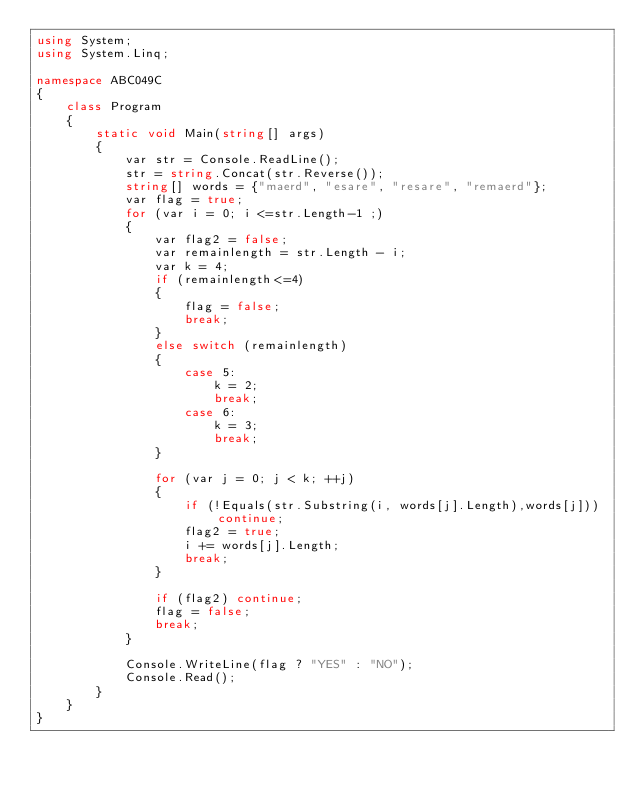Convert code to text. <code><loc_0><loc_0><loc_500><loc_500><_C#_>using System;
using System.Linq;

namespace ABC049C
{
    class Program
    {
        static void Main(string[] args)
        {
            var str = Console.ReadLine();
            str = string.Concat(str.Reverse());
            string[] words = {"maerd", "esare", "resare", "remaerd"};
            var flag = true;
            for (var i = 0; i <=str.Length-1 ;)
            {
                var flag2 = false;
                var remainlength = str.Length - i;
                var k = 4;
                if (remainlength<=4)
                {
                    flag = false;
                    break;
                }
                else switch (remainlength)
                {
                    case 5:
                        k = 2;
                        break;
                    case 6:
                        k = 3;
                        break;
                }

                for (var j = 0; j < k; ++j)
                {
                    if (!Equals(str.Substring(i, words[j].Length),words[j])) continue;
                    flag2 = true;
                    i += words[j].Length;
                    break;
                }

                if (flag2) continue;
                flag = false;
                break;
            }

            Console.WriteLine(flag ? "YES" : "NO");
            Console.Read();
        }
    }
}
</code> 